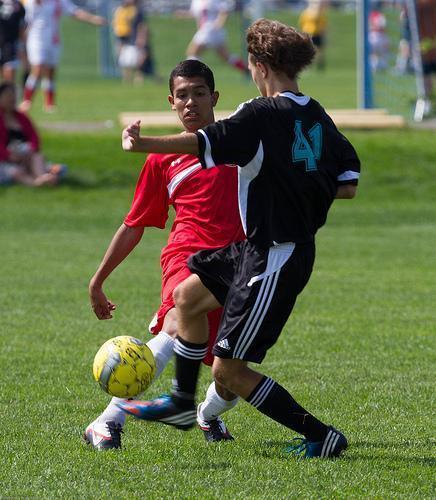How many people are playing soccer?
Give a very brief answer. 2. How many players are on the field?
Give a very brief answer. 2. 